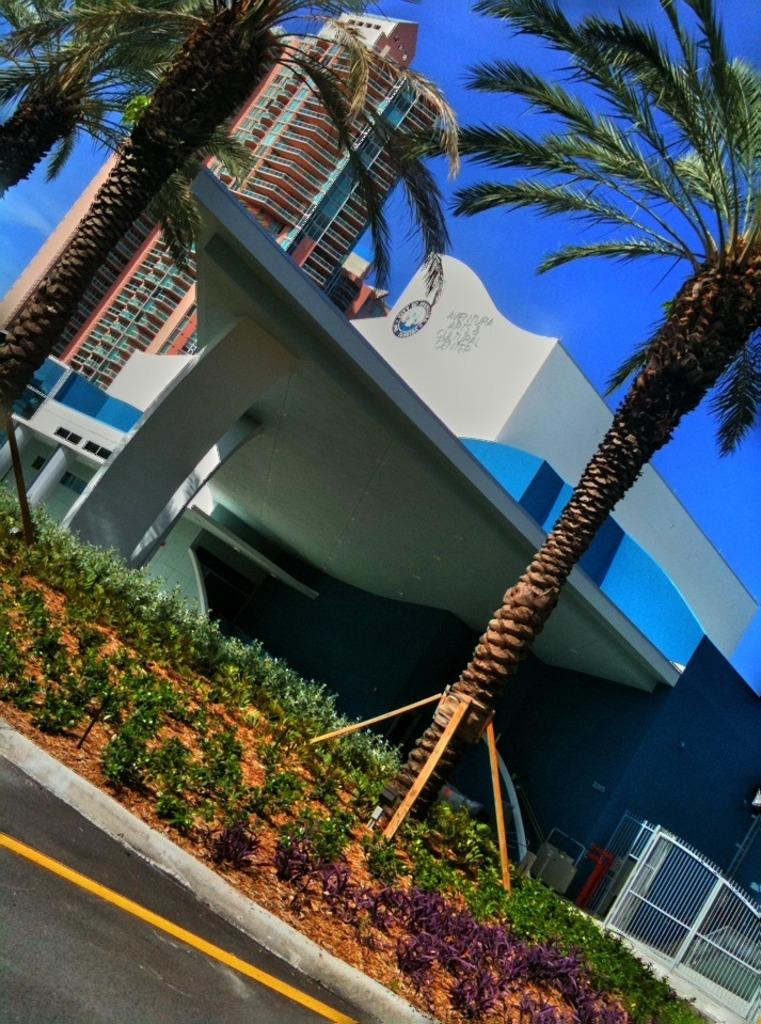What is the main feature of the image? There is a road in the image. What other elements can be seen alongside the road? There are plants and trees in the image. What can be seen in the background of the image? There are buildings in the background of the image, and the sky is clear. How many pickles are hanging from the trees in the image? There are no pickles present in the image; it features plants and trees without any pickles. What type of face can be seen on the buildings in the image? There are no faces present on the buildings in the image; they are just structures without any facial features. 